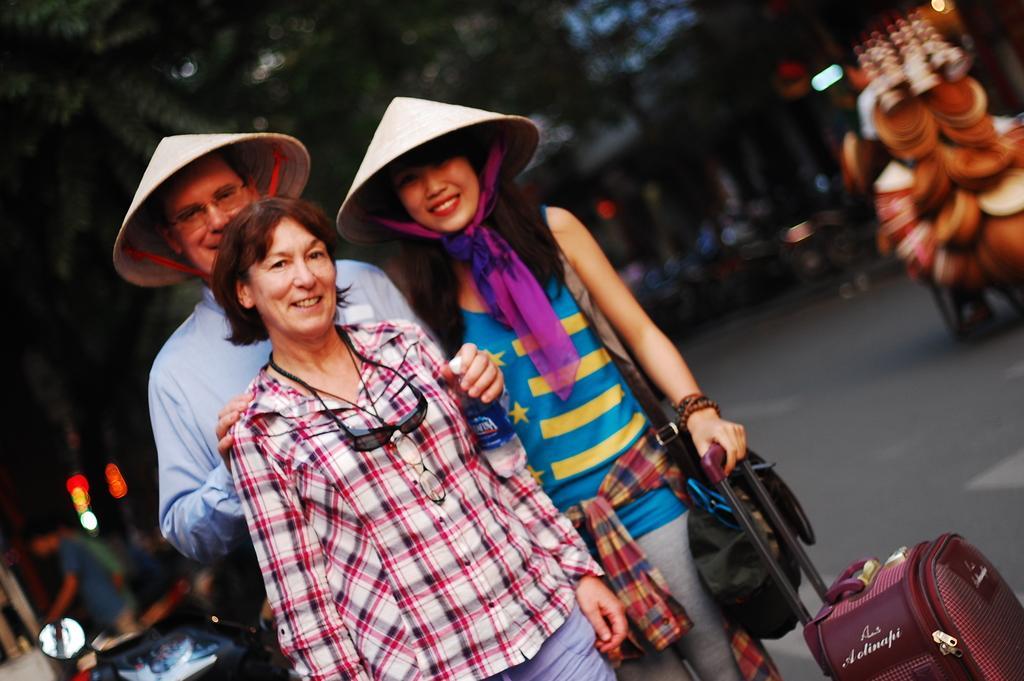In one or two sentences, can you explain what this image depicts? In this image we can see people. On the right there is a briefcase. In the background there are vehicles on the road. In the background there are trees. 